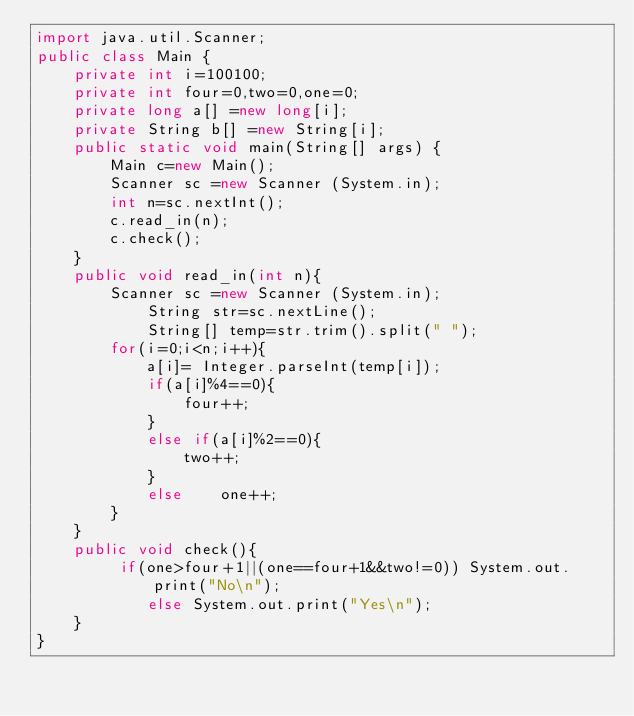<code> <loc_0><loc_0><loc_500><loc_500><_Java_>import java.util.Scanner;
public class Main {
	private int i=100100;
	private int four=0,two=0,one=0;
	private long a[] =new long[i];
	private String b[] =new String[i];
	public static void main(String[] args) {
		Main c=new Main();
		Scanner sc =new Scanner (System.in);
		int n=sc.nextInt();
		c.read_in(n);
		c.check();
	}
	public void read_in(int n){
		Scanner sc =new Scanner (System.in);	
			String str=sc.nextLine();
			String[] temp=str.trim().split(" ");
		for(i=0;i<n;i++){
			a[i]= Integer.parseInt(temp[i]);
			if(a[i]%4==0){
				four++;
			}
			else if(a[i]%2==0){
				two++;
			}
			else	one++;
		}
	}
	public void check(){
		 if(one>four+1||(one==four+1&&two!=0)) System.out.print("No\n");
	        else System.out.print("Yes\n");
	}
}</code> 